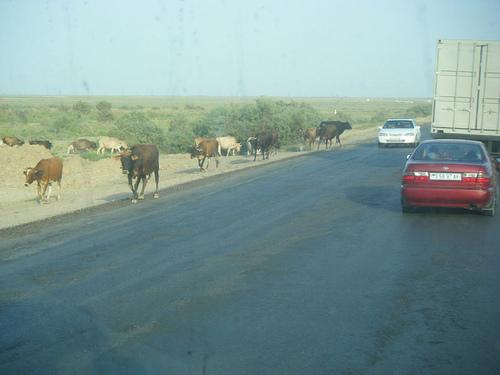Describe how the cows and other objects in the image are positioned in relation to one another. The cows are on the side of the road, close to the green bushes and trees, while the cars are on the highway with different distances between them, and the semi-truck is ahead of the red car. Tell a story about the scene depicted in the image. Several cows have wandered off near a busy highway, causing traffic to slow down as drivers take in the unusual sight. A white car followed by a maroon car cautiously make their way, while a semi-truck is further ahead. Amidst the green bushes, one cannot help but notice the clear blue sky. Point out the features of the highway that can be observed in the image. The highway features cars in motion, a semitruck, and various cows on the side, with green bushes and trees in the background. Explain what the significant elements in the image portray. The image shows various cows on the roadside, vehicles including a truck and cars on the highway, and a clear blue sky with leafy green trees in the background. Describe the different types of cows present in the image. There are dark brown, light brown, and white cows present on the road and near the dirt. Mention the primary colors and key details present in the image. The image features a clear blue sky, green trees and bushes near the road, white, red, and dark brown cows, a white car, a red car, and a semi-truck. What could be the possible outcome or danger from this situation in the image? The potential outcome or danger could be a traffic accident or injury to the cows if the drivers fail to slow down or if the cows wander onto the highway. Share your thoughts on what could have happened just before this scene took place. Before this scene, the cows might have escaped from their enclosure and found their way to the side of the highway, capturing the attention of passing motorists. Mention the colors of the cars in the image and their positions on the road. There is a white car followed by a red car on the highway, and a truck is in front of the red car. Identify the primary focus of the image and the activity taking place in it. The image mainly focuses on a group of cows on the side of a highway with some cars and a truck in motion. 